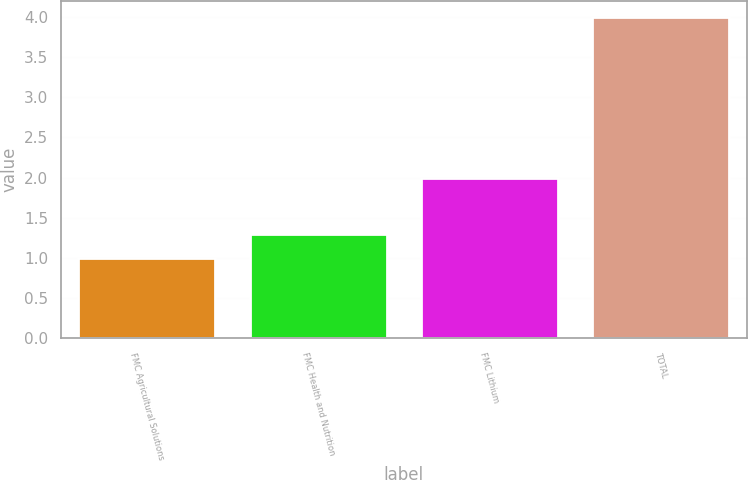Convert chart to OTSL. <chart><loc_0><loc_0><loc_500><loc_500><bar_chart><fcel>FMC Agricultural Solutions<fcel>FMC Health and Nutrition<fcel>FMC Lithium<fcel>TOTAL<nl><fcel>1<fcel>1.3<fcel>2<fcel>4<nl></chart> 